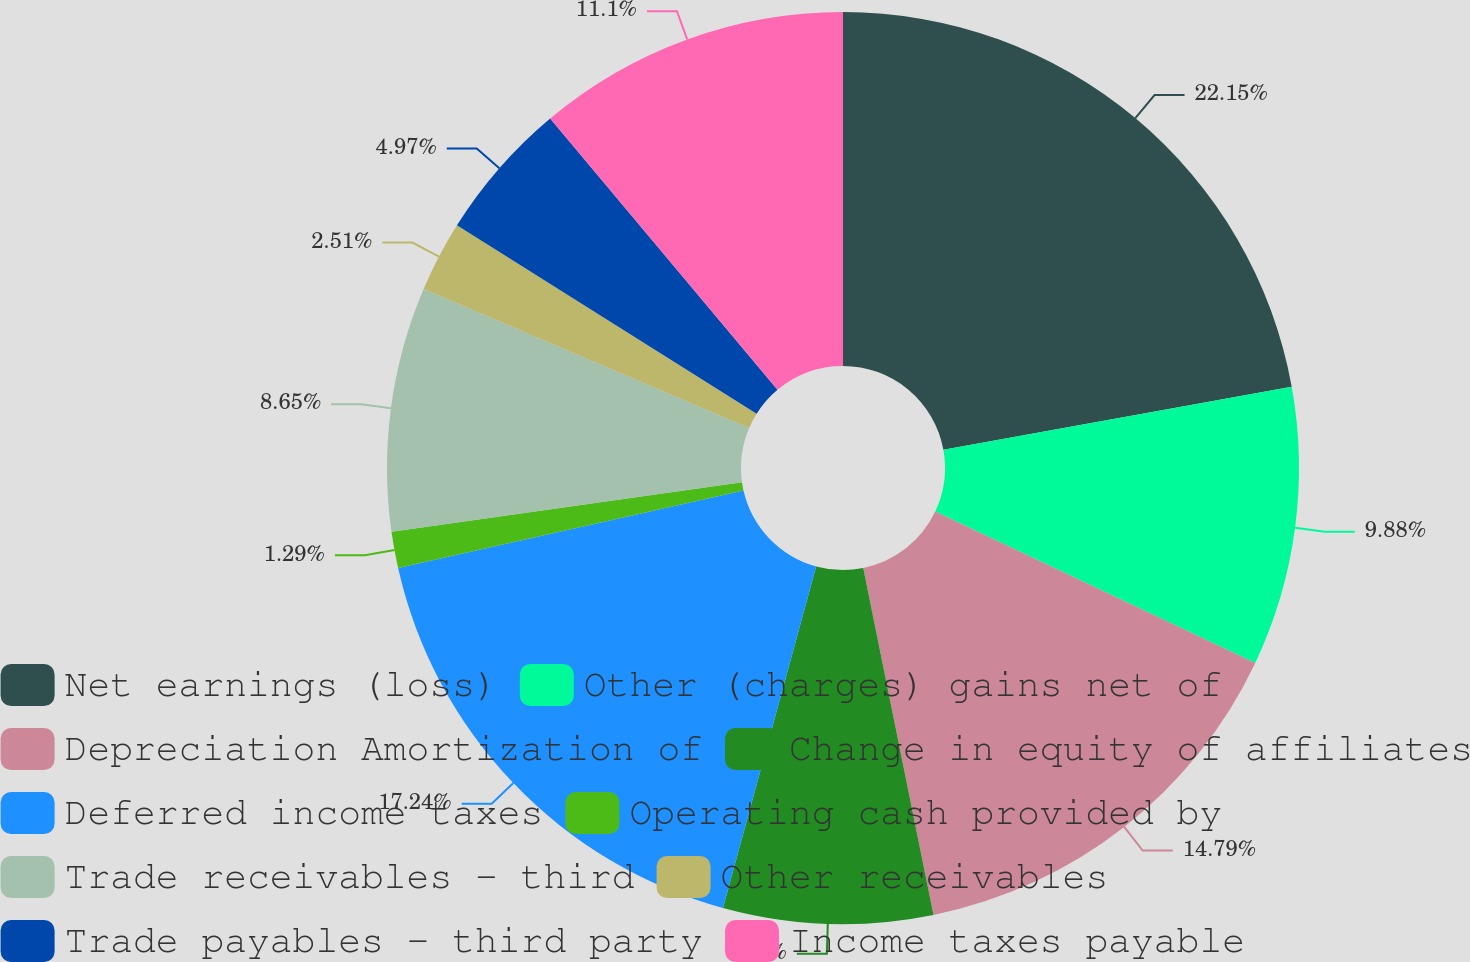Convert chart to OTSL. <chart><loc_0><loc_0><loc_500><loc_500><pie_chart><fcel>Net earnings (loss)<fcel>Other (charges) gains net of<fcel>Depreciation Amortization of<fcel>Change in equity of affiliates<fcel>Deferred income taxes<fcel>Operating cash provided by<fcel>Trade receivables - third<fcel>Other receivables<fcel>Trade payables - third party<fcel>Income taxes payable<nl><fcel>22.15%<fcel>9.88%<fcel>14.79%<fcel>7.42%<fcel>17.24%<fcel>1.29%<fcel>8.65%<fcel>2.51%<fcel>4.97%<fcel>11.1%<nl></chart> 